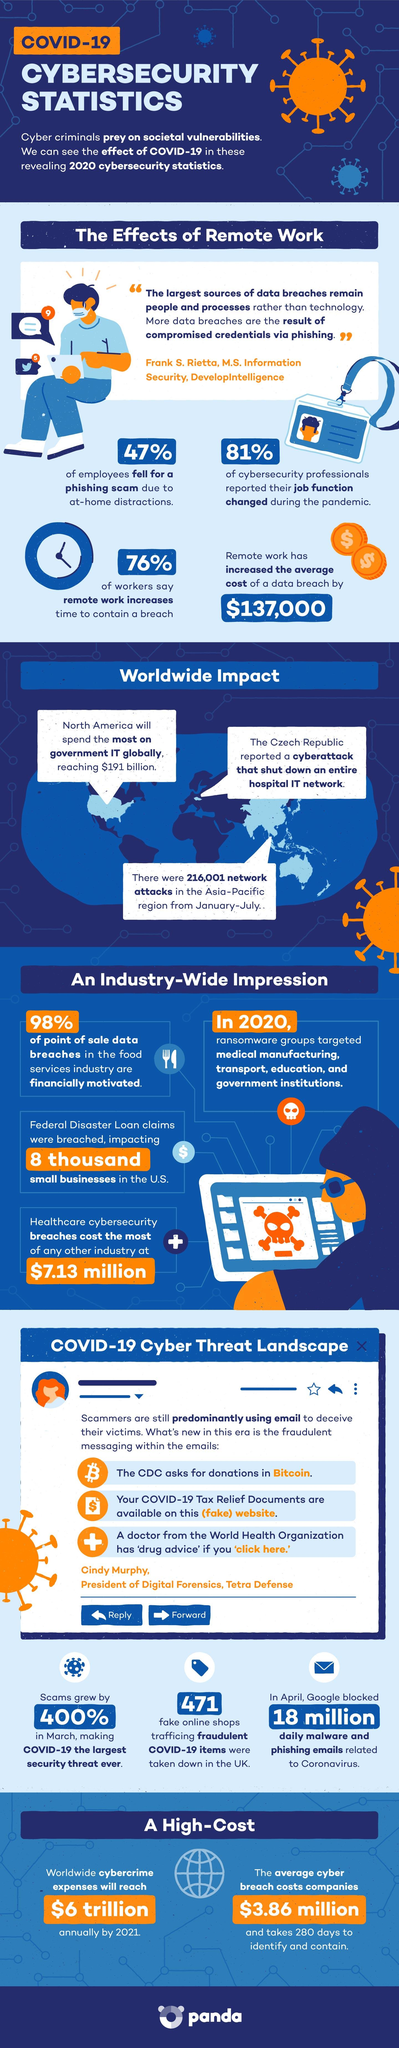Outline some significant characteristics in this image. In March, the percentage of scams grew by 400%. A recent survey found that 47% of employees fell for a phishing scam. In April, Google blocked a total of 18 million malware and phishing emails. 